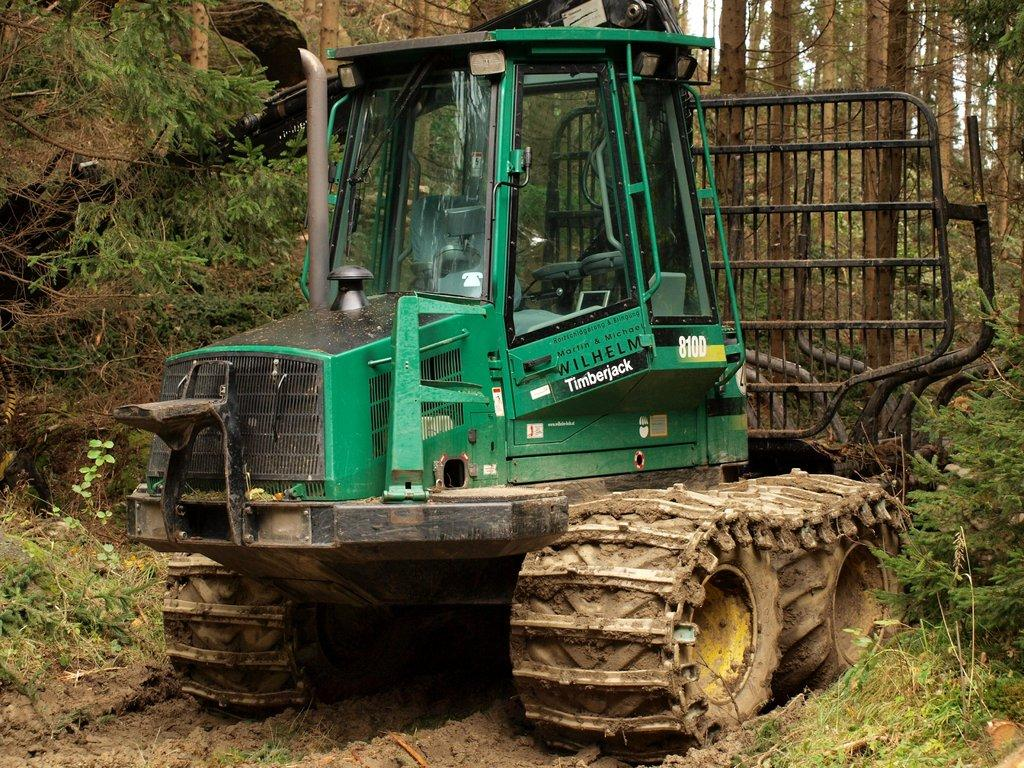What is the main subject in the center of the image? There is a tractor in the center of the image. What can be seen on the right side of the image? There are trees on the right side of the image. What can be seen on the left side of the image? There are trees on the left side of the image. What type of birthday celebration is happening in the image? There is no indication of a birthday celebration in the image. What thoughts are being expressed by the tractor in the image? Tractors do not have the ability to express thoughts, and there is no indication of any thoughts being expressed in the image. 